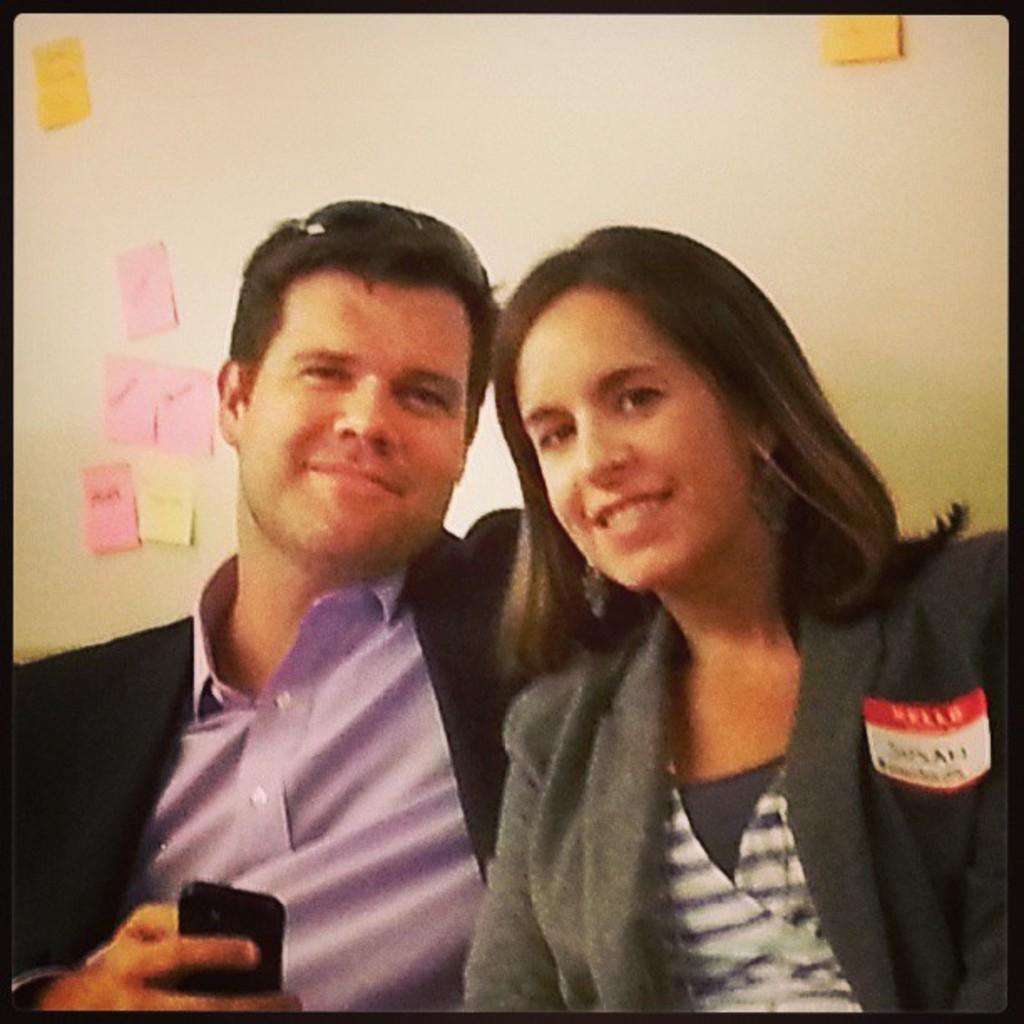Can you describe this image briefly? In this image i can see two people and one of them is holding an object, behind there is a sticky notes on the wall. 